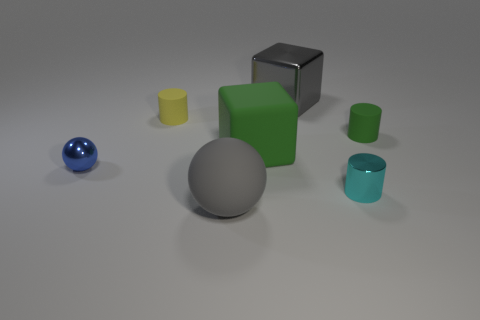Subtract 1 cylinders. How many cylinders are left? 2 Subtract all tiny rubber cylinders. How many cylinders are left? 1 Add 3 small cyan rubber spheres. How many objects exist? 10 Subtract all cylinders. How many objects are left? 4 Add 5 tiny cylinders. How many tiny cylinders exist? 8 Subtract 0 purple balls. How many objects are left? 7 Subtract all big brown cylinders. Subtract all small metallic balls. How many objects are left? 6 Add 4 matte balls. How many matte balls are left? 5 